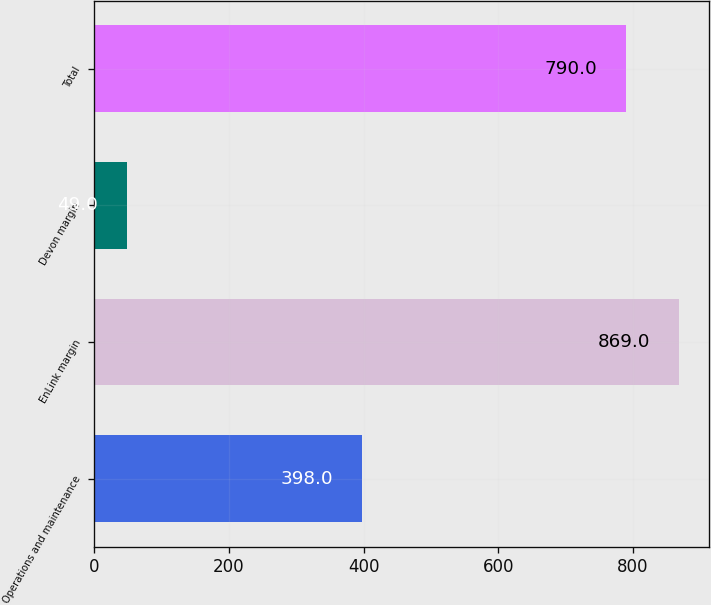Convert chart to OTSL. <chart><loc_0><loc_0><loc_500><loc_500><bar_chart><fcel>Operations and maintenance<fcel>EnLink margin<fcel>Devon margin<fcel>Total<nl><fcel>398<fcel>869<fcel>49<fcel>790<nl></chart> 